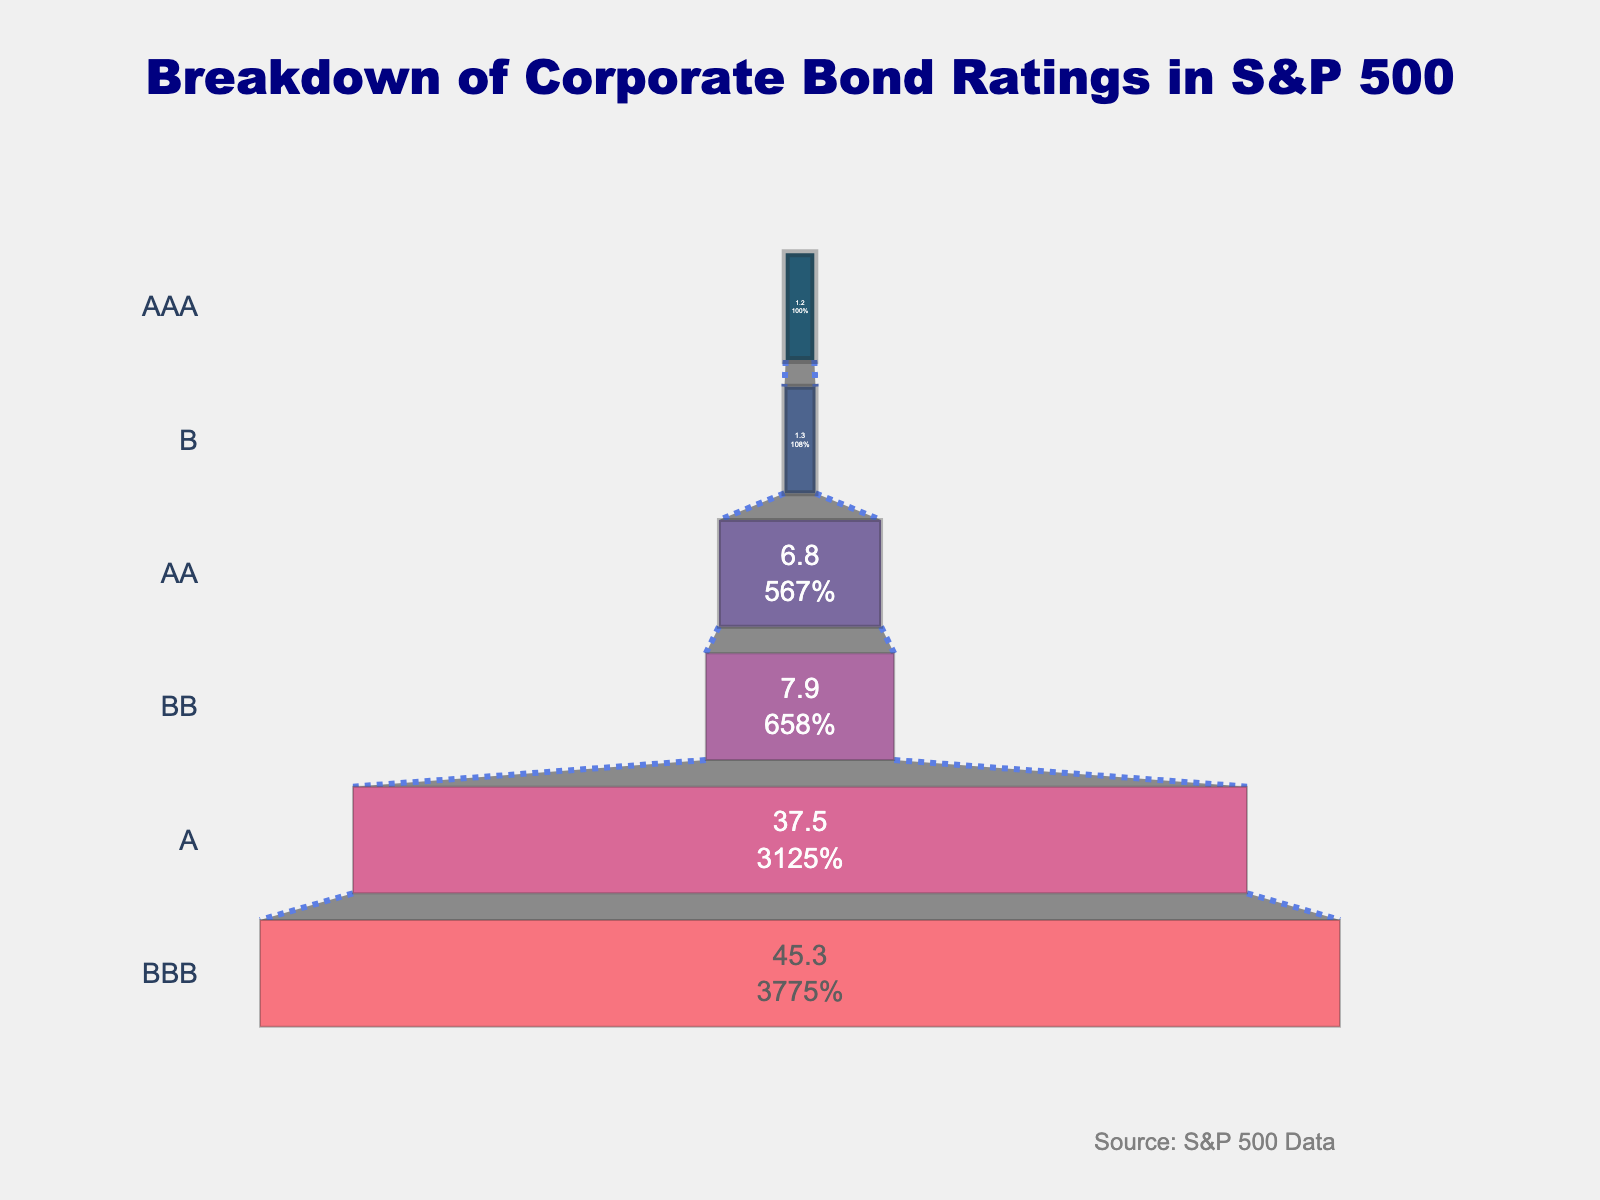What's the title of the funnel chart? The title of the funnel chart is located at the top of the figure. It clearly states what the chart is representing.
Answer: Breakdown of Corporate Bond Ratings in S&P 500 Which corporate bond rating has the highest percentage? Looking at the funnel chart, the widest section represents the highest percentage. In this chart, the "BBB" rating has the widest section.
Answer: BBB What's the combined percentage of AAA and B ratings? To find the combined percentage, add the percentages of AAA and B ratings. AAA is 1.2%, and B is 1.3%. So, 1.2 + 1.3 = 2.5%.
Answer: 2.5% Which rating has a higher percentage, AA or BB? Compare the width of the AA section with the BB section. The AA section is wider, which means it has a higher percentage.
Answer: AA What is the difference in percentage between A and BBB ratings? Subtract the percentage of A from BBB. BBB is 45.3%, and A is 37.5%. So, 45.3 - 37.5 = 7.8%.
Answer: 7.8% How many different bond ratings are represented in the figure? Count the different sections in the funnel chart, each representing a bond rating. There are a total of six sections.
Answer: 6 Is there a rating with a percentage below 2%? If yes, which one(s)? Identify sections narrower than 2% on the funnel chart. Both AAA (1.2%) and B (1.3%) fall into this category.
Answer: AAA and B What is the percentage of non-investment grade ratings (BB and below)? Add the percentages of BB and B ratings. BB is 7.9%, and B is 1.3%. So, 7.9 + 1.3 = 9.2%.
Answer: 9.2% How many ratings have a percentage greater than 5%? Identify sections in the funnel chart with percentages over 5%. There are three: AA (6.8%), A (37.5%), and BBB (45.3%).
Answer: 3 Which is greater: the sum of A and AA ratings or the BBB rating? Calculate the sum of A and AA ratings. A is 37.5%, and AA is 6.8%. So, 37.5 + 6.8 = 44.3%. Compare this to BBB, which is 45.3%. 44.3% < 45.3%.
Answer: BBB 